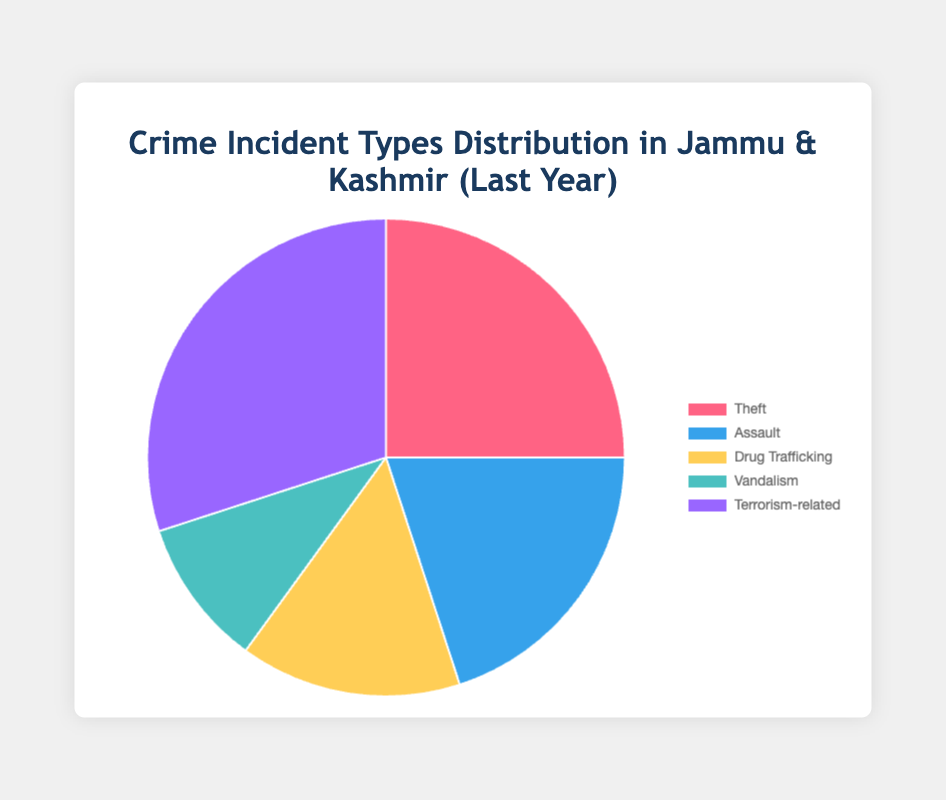What percentage of crime incidents in J&K are related to terrorism? By looking at the "Terrorism-related" segment in the pie chart, it is visible that terrorism-related incidents account for 30%.
Answer: 30% What is the combined percentage of incidents related to drug trafficking and vandalism? Drug trafficking accounts for 15% and vandalism for 10%. Adding these together: 15% + 10% = 25%
Answer: 25% Which incident type has the smallest percentage, and what is it? The "Vandalism" segment is the smallest in the pie chart, accounting for 10% of incidents.
Answer: Vandalism, 10% Is the percentage of theft incidents higher or lower than drug trafficking incidents? The pie chart shows that theft accounts for 25%, while drug trafficking is 15%. Hence, theft incidents are higher.
Answer: Higher What is the difference in percentage between assault and terrorism-related incidents? Assault incidents account for 20%, and terrorism-related incidents account for 30%. The difference is 30% - 20% = 10%.
Answer: 10% Which two types of incidents together make up more than half of the total incidents? Terrorism-related is 30% and theft is 25%. Together, they make up 30% + 25% = 55%, which is more than half.
Answer: Terrorism-related and Theft What is the percentage of incidents not related to terrorism? Terrorism-related accounts for 30%. The percentage not related to terrorism is 100% - 30% = 70%.
Answer: 70% Rank the incident types from most frequent to least frequent. Based on the pie chart, the ranking from most to least frequent is: Terrorism-related (30%), Theft (25%), Assault (20%), Drug Trafficking (15%), Vandalism (10%).
Answer: Terrorism-related, Theft, Assault, Drug Trafficking, Vandalism If a new incident type with a 5% rate were introduced, how would this affect the overall percentages? The total percentage without the new incident is 100%. With the new incident, total is 105%. So each original percentage should be adjusted accordingly (e.g., 30% becomes (30/105)*100%). However, exact numbers would need recalculating for precisions.
Answer: The percentages would need recalculating to fit into a total of 100% What percentage more of theft incidents are there than vandalism incidents? Theft is 25% and vandalism is 10%. The percentage more is calculated as the difference: 25% - 10% = 15%.
Answer: 15% 